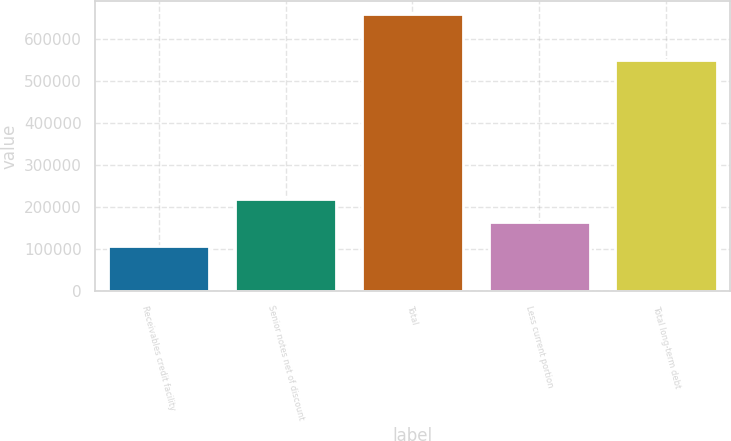<chart> <loc_0><loc_0><loc_500><loc_500><bar_chart><fcel>Receivables credit facility<fcel>Senior notes net of discount<fcel>Total<fcel>Less current portion<fcel>Total long-term debt<nl><fcel>109000<fcel>218820<fcel>658099<fcel>163910<fcel>549099<nl></chart> 